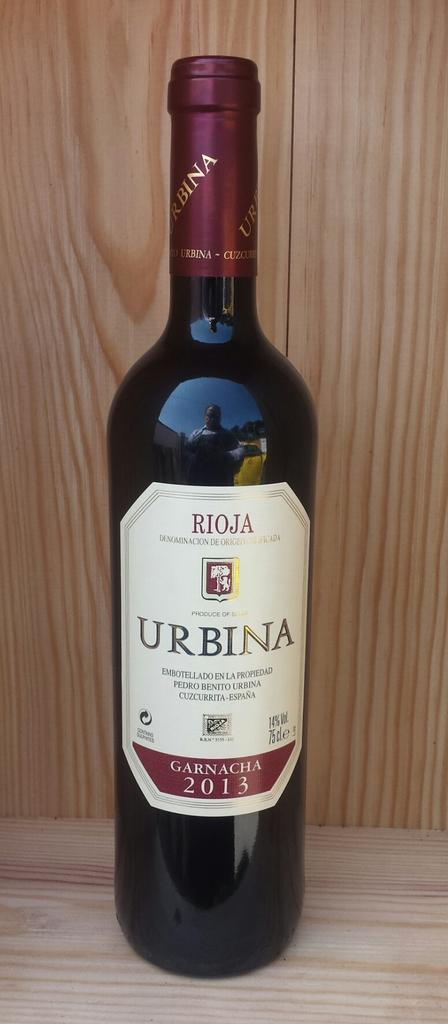<image>
Share a concise interpretation of the image provided. A bottle of Rioja Urbina Garnacha from 2013 on a wooden surface. 